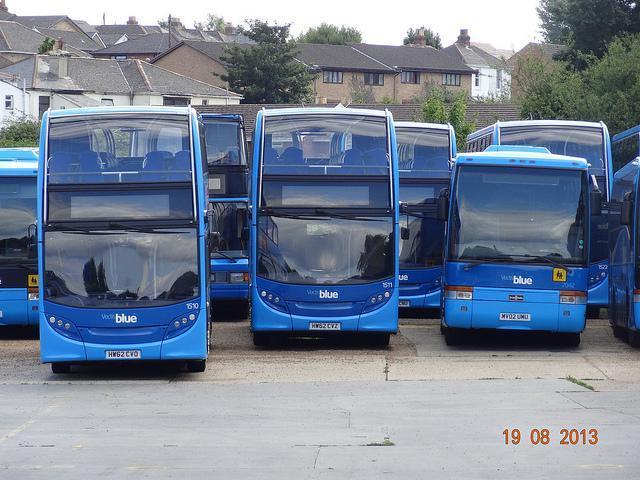How many buses are there?
Give a very brief answer. 8. How many buses can you see?
Give a very brief answer. 8. How many people can sit on this couch?
Give a very brief answer. 0. 